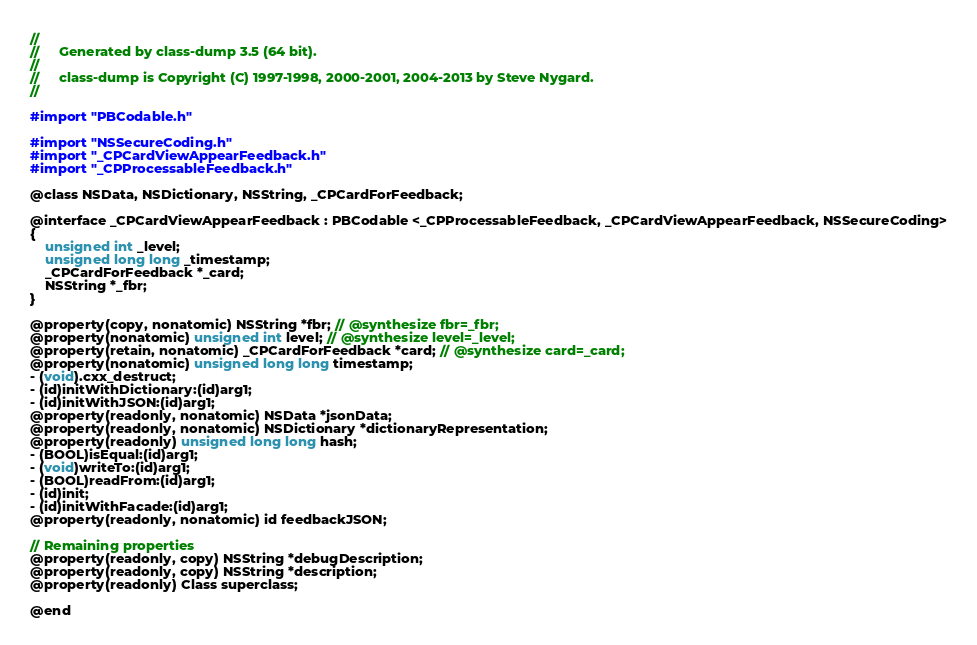<code> <loc_0><loc_0><loc_500><loc_500><_C_>//
//     Generated by class-dump 3.5 (64 bit).
//
//     class-dump is Copyright (C) 1997-1998, 2000-2001, 2004-2013 by Steve Nygard.
//

#import "PBCodable.h"

#import "NSSecureCoding.h"
#import "_CPCardViewAppearFeedback.h"
#import "_CPProcessableFeedback.h"

@class NSData, NSDictionary, NSString, _CPCardForFeedback;

@interface _CPCardViewAppearFeedback : PBCodable <_CPProcessableFeedback, _CPCardViewAppearFeedback, NSSecureCoding>
{
    unsigned int _level;
    unsigned long long _timestamp;
    _CPCardForFeedback *_card;
    NSString *_fbr;
}

@property(copy, nonatomic) NSString *fbr; // @synthesize fbr=_fbr;
@property(nonatomic) unsigned int level; // @synthesize level=_level;
@property(retain, nonatomic) _CPCardForFeedback *card; // @synthesize card=_card;
@property(nonatomic) unsigned long long timestamp;
- (void).cxx_destruct;
- (id)initWithDictionary:(id)arg1;
- (id)initWithJSON:(id)arg1;
@property(readonly, nonatomic) NSData *jsonData;
@property(readonly, nonatomic) NSDictionary *dictionaryRepresentation;
@property(readonly) unsigned long long hash;
- (BOOL)isEqual:(id)arg1;
- (void)writeTo:(id)arg1;
- (BOOL)readFrom:(id)arg1;
- (id)init;
- (id)initWithFacade:(id)arg1;
@property(readonly, nonatomic) id feedbackJSON;

// Remaining properties
@property(readonly, copy) NSString *debugDescription;
@property(readonly, copy) NSString *description;
@property(readonly) Class superclass;

@end

</code> 